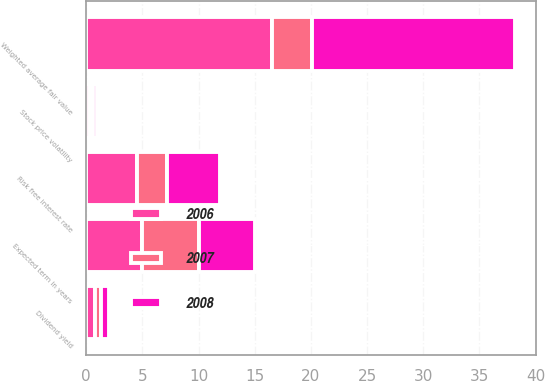Convert chart to OTSL. <chart><loc_0><loc_0><loc_500><loc_500><stacked_bar_chart><ecel><fcel>Risk free interest rate<fcel>Stock price volatility<fcel>Dividend yield<fcel>Expected term in years<fcel>Weighted average fair value<nl><fcel>2007<fcel>2.7<fcel>0.29<fcel>0.5<fcel>5<fcel>3.6<nl><fcel>2008<fcel>4.7<fcel>0.32<fcel>0.75<fcel>5<fcel>18.07<nl><fcel>2006<fcel>4.5<fcel>0.32<fcel>0.8<fcel>5<fcel>16.5<nl></chart> 